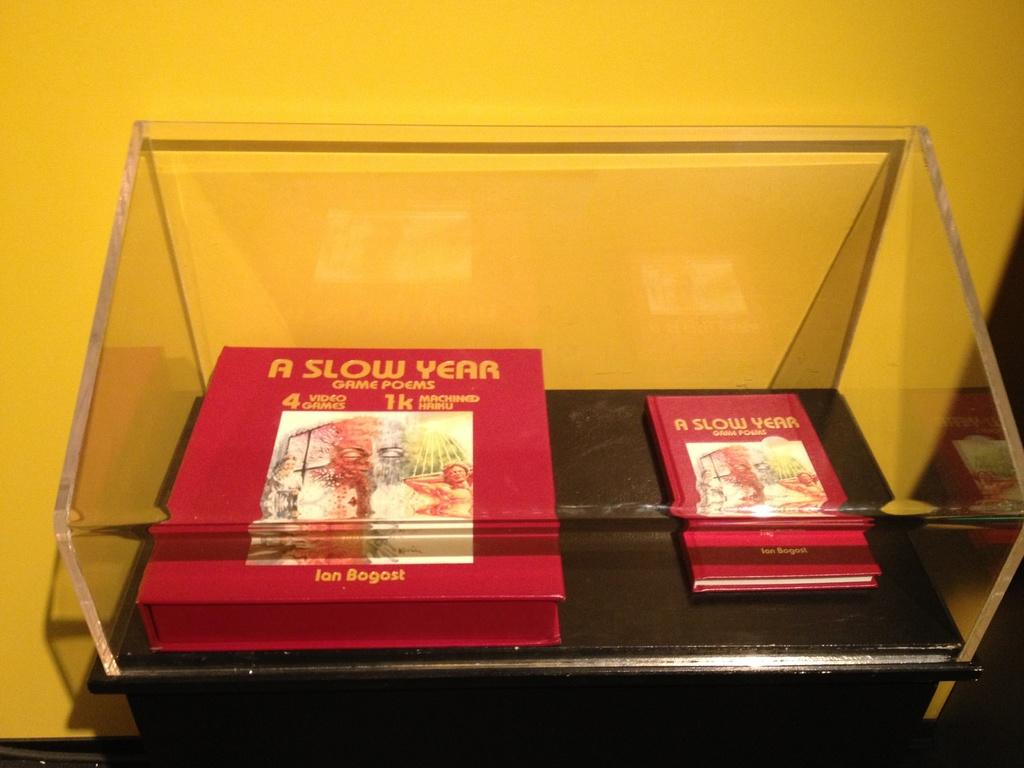<image>
Write a terse but informative summary of the picture. Two books with A Slow Year on the cover inside of a glass box. 